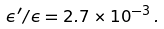<formula> <loc_0><loc_0><loc_500><loc_500>\epsilon ^ { \prime } / \epsilon = 2 . 7 \times 1 0 ^ { - 3 } \, .</formula> 